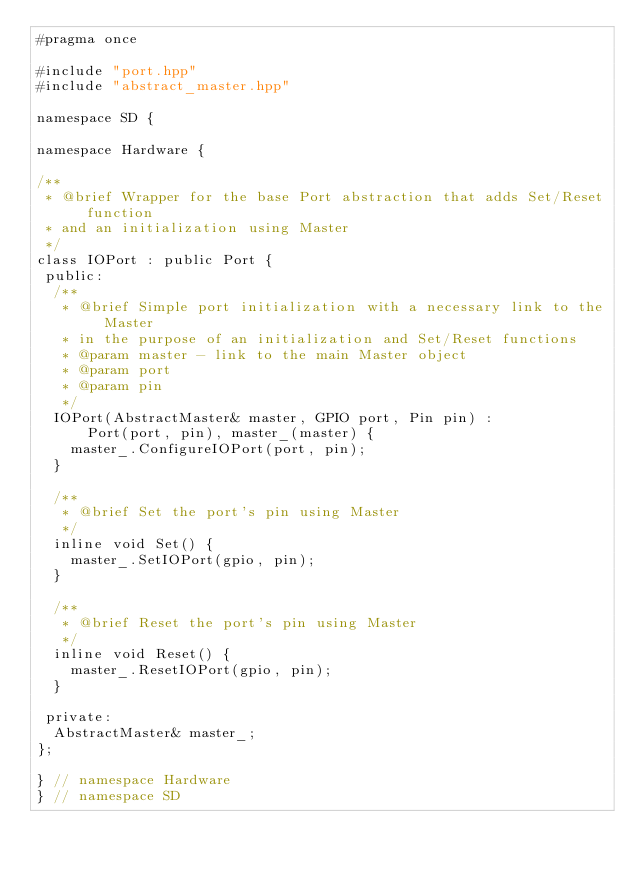<code> <loc_0><loc_0><loc_500><loc_500><_C++_>#pragma once

#include "port.hpp"
#include "abstract_master.hpp"

namespace SD {

namespace Hardware {

/**
 * @brief Wrapper for the base Port abstraction that adds Set/Reset function
 * and an initialization using Master
 */
class IOPort : public Port {
 public:
  /**
   * @brief Simple port initialization with a necessary link to the Master
   * in the purpose of an initialization and Set/Reset functions
   * @param master - link to the main Master object
   * @param port
   * @param pin
   */
  IOPort(AbstractMaster& master, GPIO port, Pin pin) :
      Port(port, pin), master_(master) {
    master_.ConfigureIOPort(port, pin);
  }

  /**
   * @brief Set the port's pin using Master
   */
  inline void Set() {
    master_.SetIOPort(gpio, pin);
  }

  /**
   * @brief Reset the port's pin using Master
   */
  inline void Reset() {
    master_.ResetIOPort(gpio, pin);
  }

 private:
  AbstractMaster& master_;
};

} // namespace Hardware
} // namespace SD
</code> 